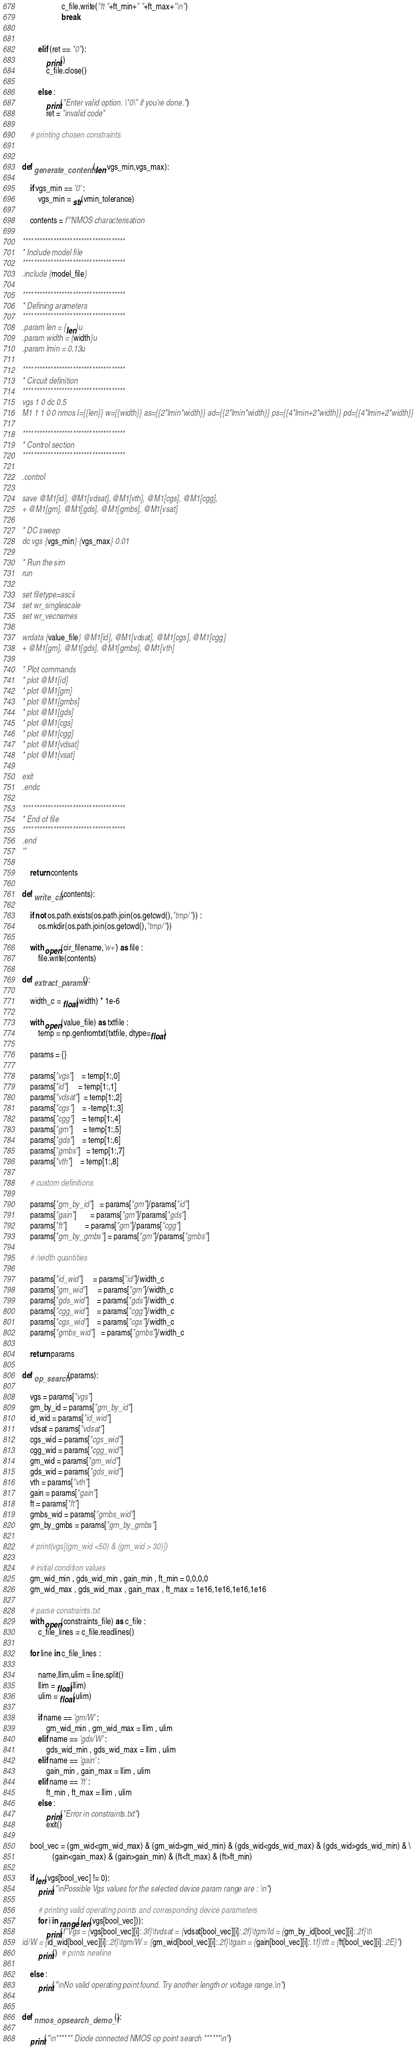<code> <loc_0><loc_0><loc_500><loc_500><_Python_>                    c_file.write("ft "+ft_min+" "+ft_max+"\n")
                    break
                

        elif (ret == "0"):
            print()
            c_file.close()

        else :
            print("Enter valid option. \"0\" if you're done.")
            ret = "invalid code"

    # printing chosen constraints
    
    
def generate_contents(len,vgs_min,vgs_max):
    
    if vgs_min == '0' :
        vgs_min = str(vmin_tolerance)
    
    contents = f'''NMOS characterisation

*************************************
* Include model file 
*************************************
.include {model_file}

*************************************
* Defining arameters 
*************************************
.param len = {len}u
.param width = {width}u 
.param lmin = 0.13u

*************************************
* Circuit definition
*************************************
vgs 1 0 dc 0.5
M1 1 1 0 0 nmos l={{len}} w={{width}} as={{2*lmin*width}} ad={{2*lmin*width}} ps={{4*lmin+2*width}} pd={{4*lmin+2*width}}

*************************************
* Control section
*************************************

.control 

save @M1[id], @M1[vdsat], @M1[vth], @M1[cgs], @M1[cgg],
+ @M1[gm], @M1[gds], @M1[gmbs], @M1[vsat]

* DC sweep
dc vgs {vgs_min} {vgs_max} 0.01

* Run the sim
run

set filetype=ascii
set wr_singlescale
set wr_vecnames

wrdata {value_file} @M1[id], @M1[vdsat], @M1[cgs], @M1[cgg] 
+ @M1[gm], @M1[gds], @M1[gmbs], @M1[vth]

* Plot commands
* plot @M1[id]
* plot @M1[gm]
* plot @M1[gmbs]
* plot @M1[gds]
* plot @M1[cgs]
* plot @M1[cgg]
* plot @M1[vdsat]
* plot @M1[vsat]

exit
.endc

*************************************
* End of file
*************************************
.end
'''

    return contents

def write_cir(contents):
    
    if not os.path.exists(os.path.join(os.getcwd(),"tmp/")) :
        os.mkdir(os.path.join(os.getcwd(),"tmp/"))
        
    with open(cir_filename,'w+') as file :
        file.write(contents)

def extract_params():
    
    width_c = float(width) * 1e-6

    with open(value_file) as txtfile :
        temp = np.genfromtxt(txtfile, dtype=float)

    params = {}

    params["vgs"]    = temp[1:,0]
    params["id"]     = temp[1:,1]
    params["vdsat"]  = temp[1:,2]
    params["cgs"]    = -temp[1:,3]
    params["cgg"]    = temp[1:,4]
    params["gm"]     = temp[1:,5]
    params["gds"]    = temp[1:,6]
    params["gmbs"]   = temp[1:,7]
    params["vth"]    = temp[1:,8]

    # custom definitions

    params["gm_by_id"]   = params["gm"]/params["id"] 
    params["gain"]       = params["gm"]/params["gds"]
    params["ft"]         = params["gm"]/params["cgg"]
    params["gm_by_gmbs"] = params["gm"]/params["gmbs"]

    # /width quantities

    params["id_wid"]     = params["id"]/width_c
    params["gm_wid"]     = params["gm"]/width_c
    params["gds_wid"]    = params["gds"]/width_c
    params["cgg_wid"]    = params["cgg"]/width_c
    params["cgs_wid"]    = params["cgs"]/width_c
    params["gmbs_wid"]   = params["gmbs"]/width_c

    return params

def op_search(params):
    
    vgs = params["vgs"]
    gm_by_id = params["gm_by_id"]
    id_wid = params["id_wid"]
    vdsat = params["vdsat"]
    cgs_wid = params["cgs_wid"]
    cgg_wid = params["cgg_wid"]
    gm_wid = params["gm_wid"]
    gds_wid = params["gds_wid"]
    vth = params["vth"]
    gain = params["gain"]
    ft = params["ft"]
    gmbs_wid = params["gmbs_wid"]
    gm_by_gmbs = params["gm_by_gmbs"]
    
    # print(vgs[(gm_wid <50) & (gm_wid > 30)])

    # initial condition values
    gm_wid_min , gds_wid_min , gain_min , ft_min = 0,0,0,0
    gm_wid_max , gds_wid_max , gain_max , ft_max = 1e16,1e16,1e16,1e16 
    
    # parse constraints.txt
    with open(constraints_file) as c_file :
        c_file_lines = c_file.readlines()
    
    for line in c_file_lines :
        
        name,llim,ulim = line.split()
        llim = float(llim)
        ulim = float(ulim)

        if name == 'gm/W' :
            gm_wid_min , gm_wid_max = llim , ulim 
        elif name == 'gds/W' :
            gds_wid_min , gds_wid_max = llim , ulim
        elif name == 'gain' :
            gain_min , gain_max = llim , ulim
        elif name == 'ft' :
            ft_min , ft_max = llim , ulim
        else :
            print("Error in constraints.txt")
            exit()
    
    bool_vec = (gm_wid<gm_wid_max) & (gm_wid>gm_wid_min) & (gds_wid<gds_wid_max) & (gds_wid>gds_wid_min) & \
               (gain<gain_max) & (gain>gain_min) & (ft<ft_max) & (ft>ft_min)

    if len(vgs[bool_vec] != 0):
        print("\nPossible Vgs values for the selected device param range are : \n")
        
        # printing valid operating points and corresponding device parameters
        for i in range(len(vgs[bool_vec])):
            print(f"Vgs = {vgs[bool_vec][i]:.3f}\tvdsat = {vdsat[bool_vec][i]:.2f}\tgm/Id = {gm_by_id[bool_vec][i]:.2f}\t\
id/W = {id_wid[bool_vec][i]:.2f}\tgm/W = {gm_wid[bool_vec][i]:.2f}\tgain = {gain[bool_vec][i]:.1f}\tft = {ft[bool_vec][i]:.2E}")
        print()  # prints newline

    else :
        print("\nNo valid operating point found. Try another length or voltage range.\n")


def nmos_opsearch_demo_1():

    print("\n****** Diode connected NMOS op point search ******\n")</code> 